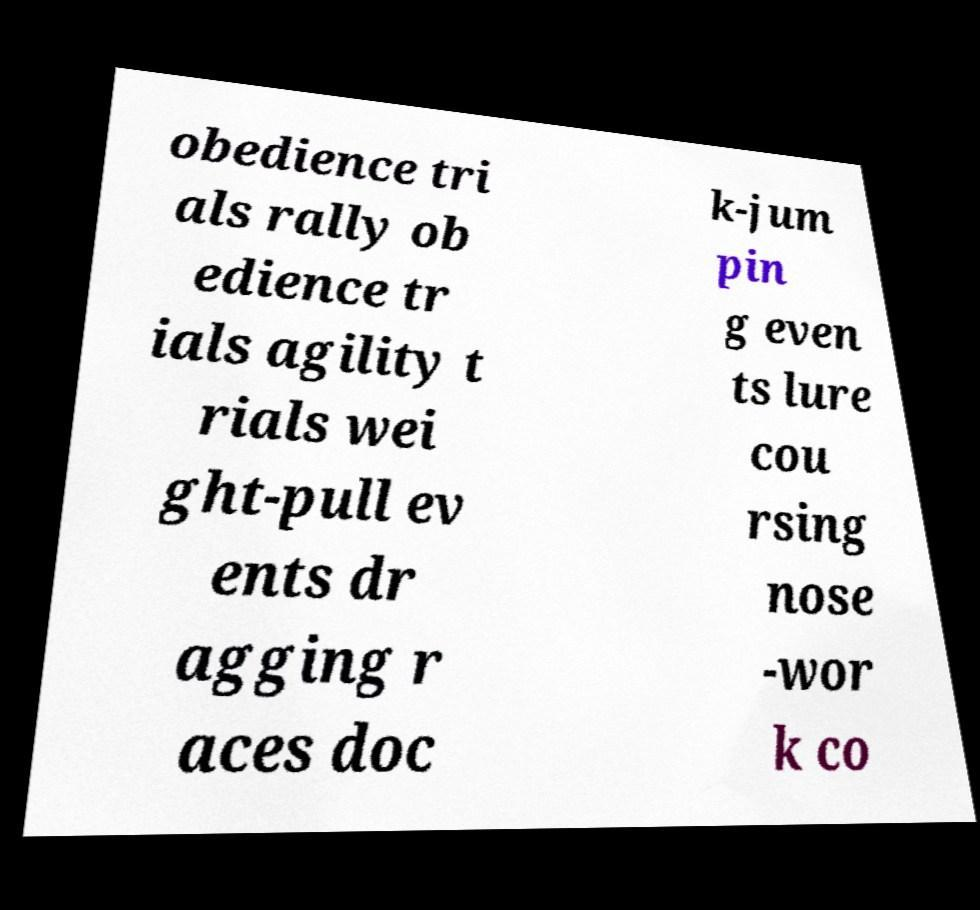Please identify and transcribe the text found in this image. obedience tri als rally ob edience tr ials agility t rials wei ght-pull ev ents dr agging r aces doc k-jum pin g even ts lure cou rsing nose -wor k co 